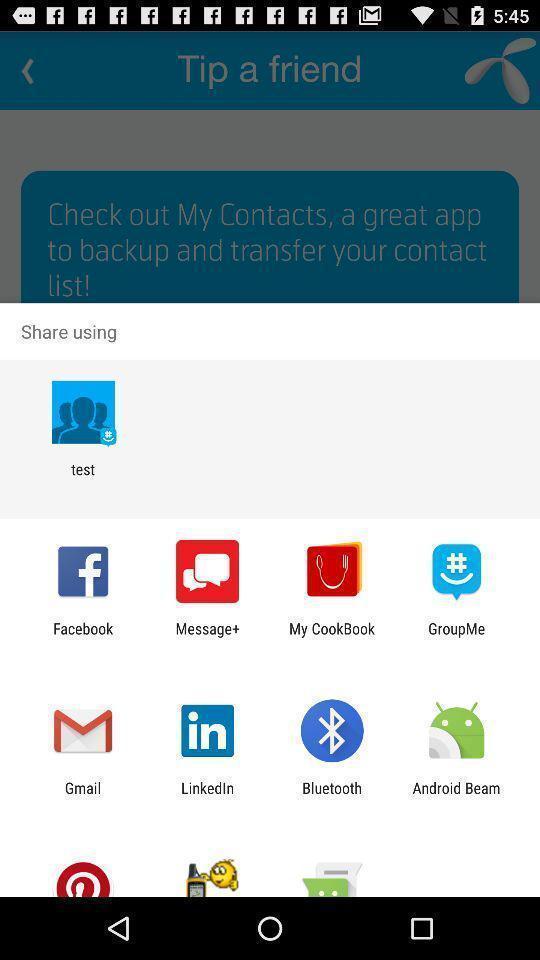Give me a summary of this screen capture. Pop-up with options to choose an app to share. 